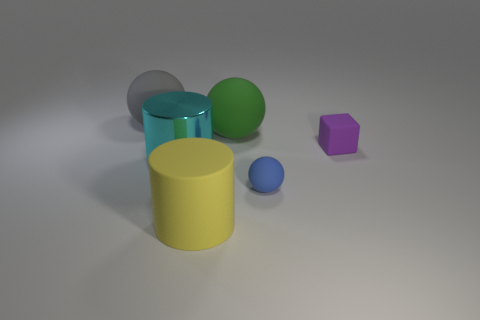Is the material of the blue ball the same as the cyan thing that is in front of the green matte thing?
Offer a terse response. No. What number of blue matte objects are behind the matte sphere that is in front of the cylinder on the left side of the yellow rubber thing?
Your response must be concise. 0. What number of blue things are either blocks or matte spheres?
Provide a succinct answer. 1. The big gray matte thing that is left of the metallic cylinder has what shape?
Keep it short and to the point. Sphere. There is another metallic cylinder that is the same size as the yellow cylinder; what color is it?
Your answer should be compact. Cyan. There is a big gray matte object; is it the same shape as the tiny thing that is in front of the big cyan cylinder?
Offer a very short reply. Yes. What is the big cylinder that is behind the ball that is to the right of the big green rubber ball behind the metallic thing made of?
Your answer should be compact. Metal. What number of tiny objects are cyan things or yellow cylinders?
Keep it short and to the point. 0. How many other things are the same size as the yellow rubber object?
Offer a very short reply. 3. There is a tiny matte thing left of the tiny purple thing; is it the same shape as the big green matte thing?
Give a very brief answer. Yes. 